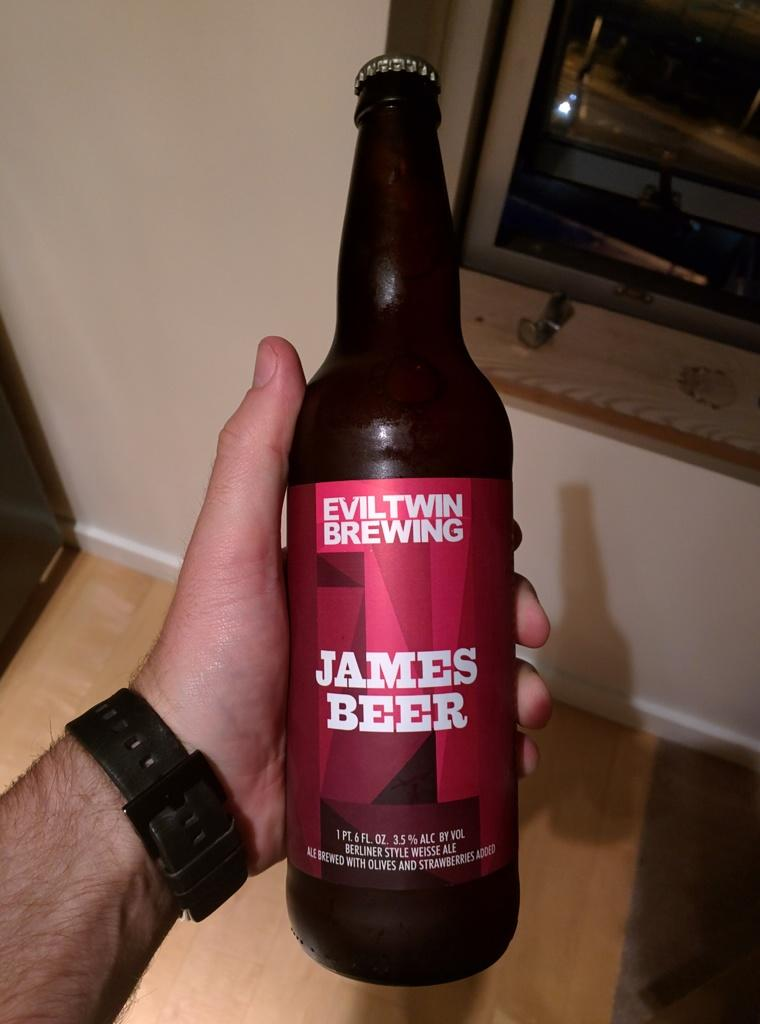<image>
Summarize the visual content of the image. A man is holding a James beer in one hand. 